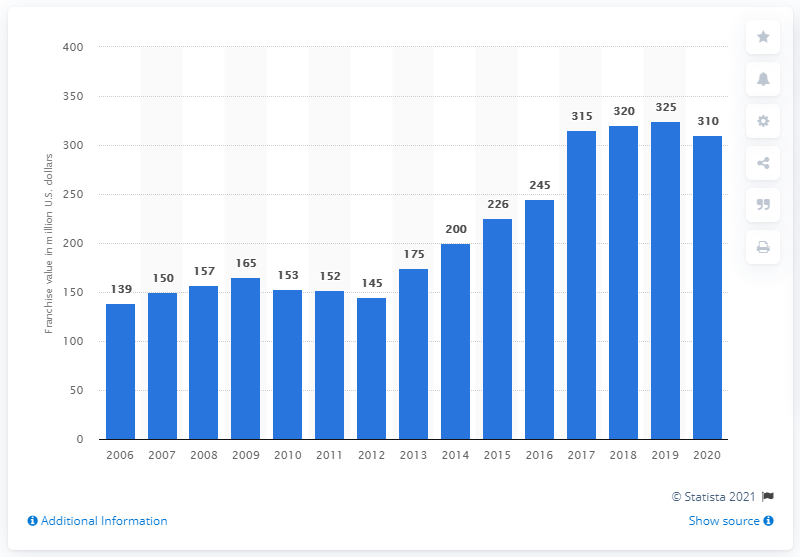What year saw the highest value of the franchise, and what might have influenced this peak? 2019 was the year when the Columbus Blue Jackets franchise reached its highest value at 325 million dollars. This peak could be attributed to various factors including team performance, economic conditions, and increased fan engagement and sponsorships during that period. 